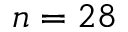Convert formula to latex. <formula><loc_0><loc_0><loc_500><loc_500>n = 2 8</formula> 